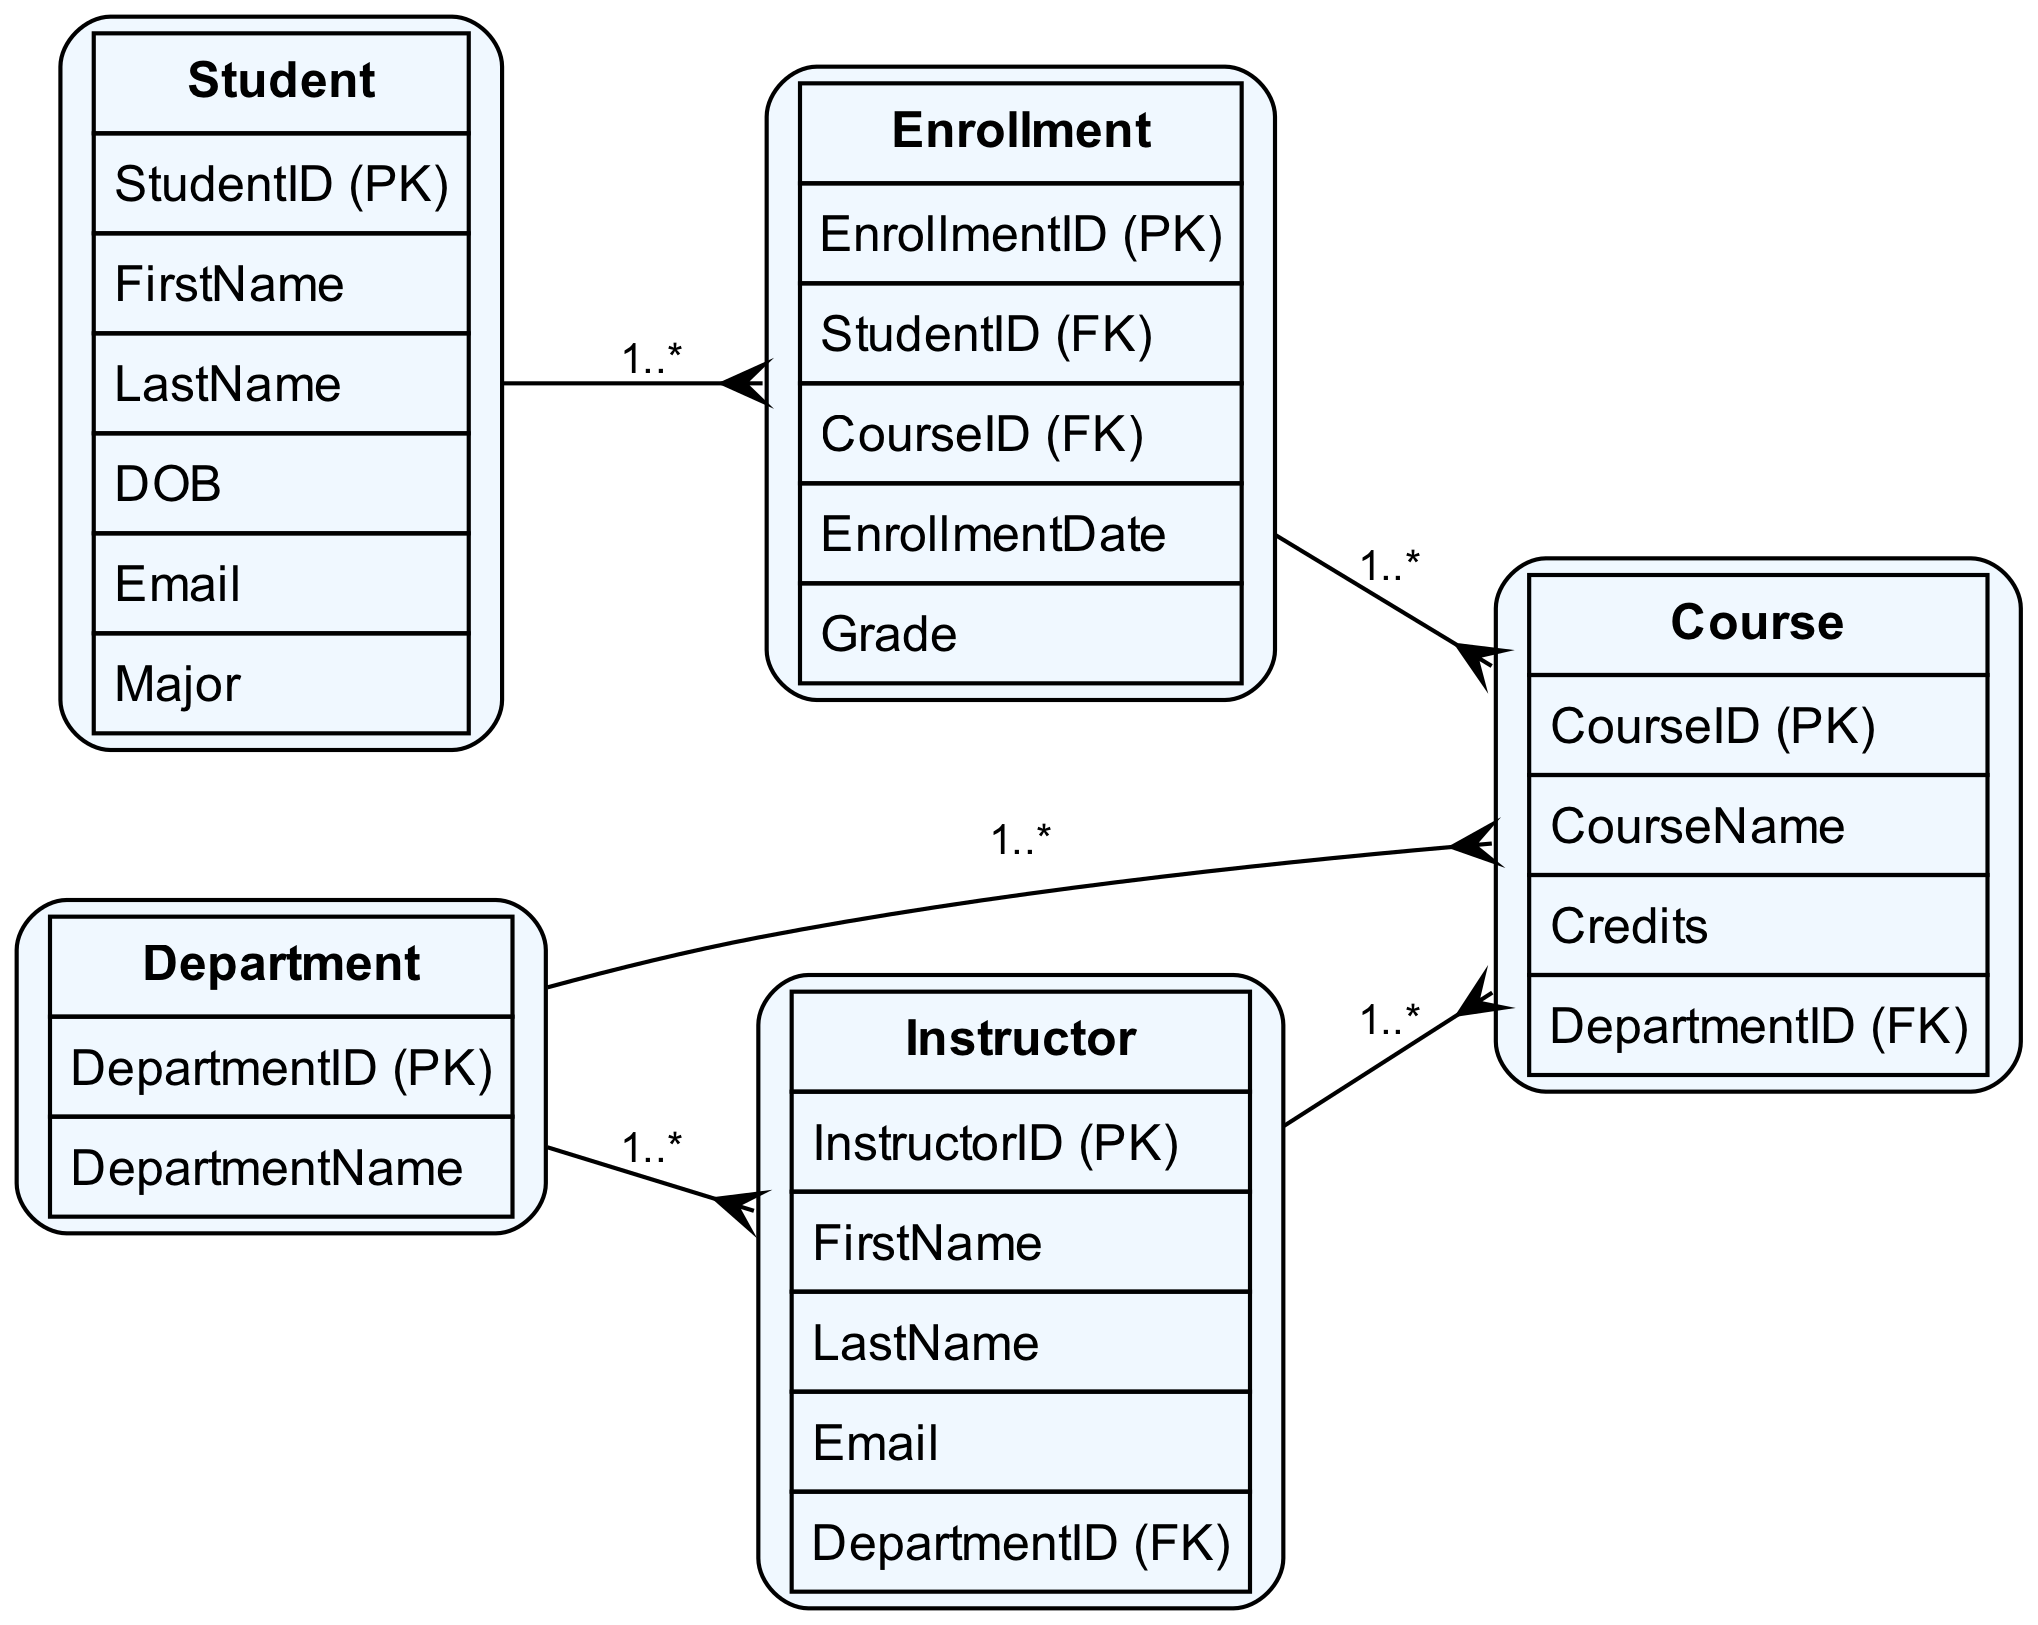What is the primary key of the Student entity? The primary key for the Student entity is listed in the attributes section as "StudentID (PK)", indicating it uniquely identifies each student in the database.
Answer: StudentID How many entities are there in the diagram? The diagram includes five entities: Student, Course, Instructor, Department, and Enrollment; thus, the count is derived directly from the list of entities provided.
Answer: 5 What relationship type exists between Student and Course? The relationship type stated in the diagram is "Many-to-Many", as indicated in the relationships section, showing that students can enroll in multiple courses and each course can have many students enrolled.
Answer: Many-to-Many Which entity does the Course entity reference as a foreign key? The Course entity includes an attribute "DepartmentID (FK)," which indicates that it references the Department entity to establish the relationship between courses and their respective departments.
Answer: Department How many attributes does the Instructor entity have? Counting the attributes listed under the Instructor entity, there are five: InstructorID, FirstName, LastName, Email, and DepartmentID; thus, the number of attributes is directly counted from the list.
Answer: 5 What entity employs Instructors? The diagram indicates that Departments employ Instructors; this is evident from the "One-to-Many" relationship shown between Department and Instructor in the relationships section.
Answer: Department What is the minimum count of Courses a Department can offer? The diagram suggests that each Department can offer one or more Courses, as is typical in a "One-to-Many" relationship, which indicates that a Department can have zero to many Courses, making the minimum count zero.
Answer: 0 Which entity serves as the linking table for the Student and Course relationship? The diagram defines that the Enrollment entity serves as the linking table for the Many-to-Many relationship between Students and Courses, facilitating enrollment records for each student in the corresponding courses.
Answer: Enrollment How many attributes are in the Enrollment entity? The attributes listed under the Enrollment entity are EnrollmentID, StudentID, CourseID, EnrollmentDate, and Grade, totaling to five attributes, which can be summed up by directly counting the provided attributes.
Answer: 5 